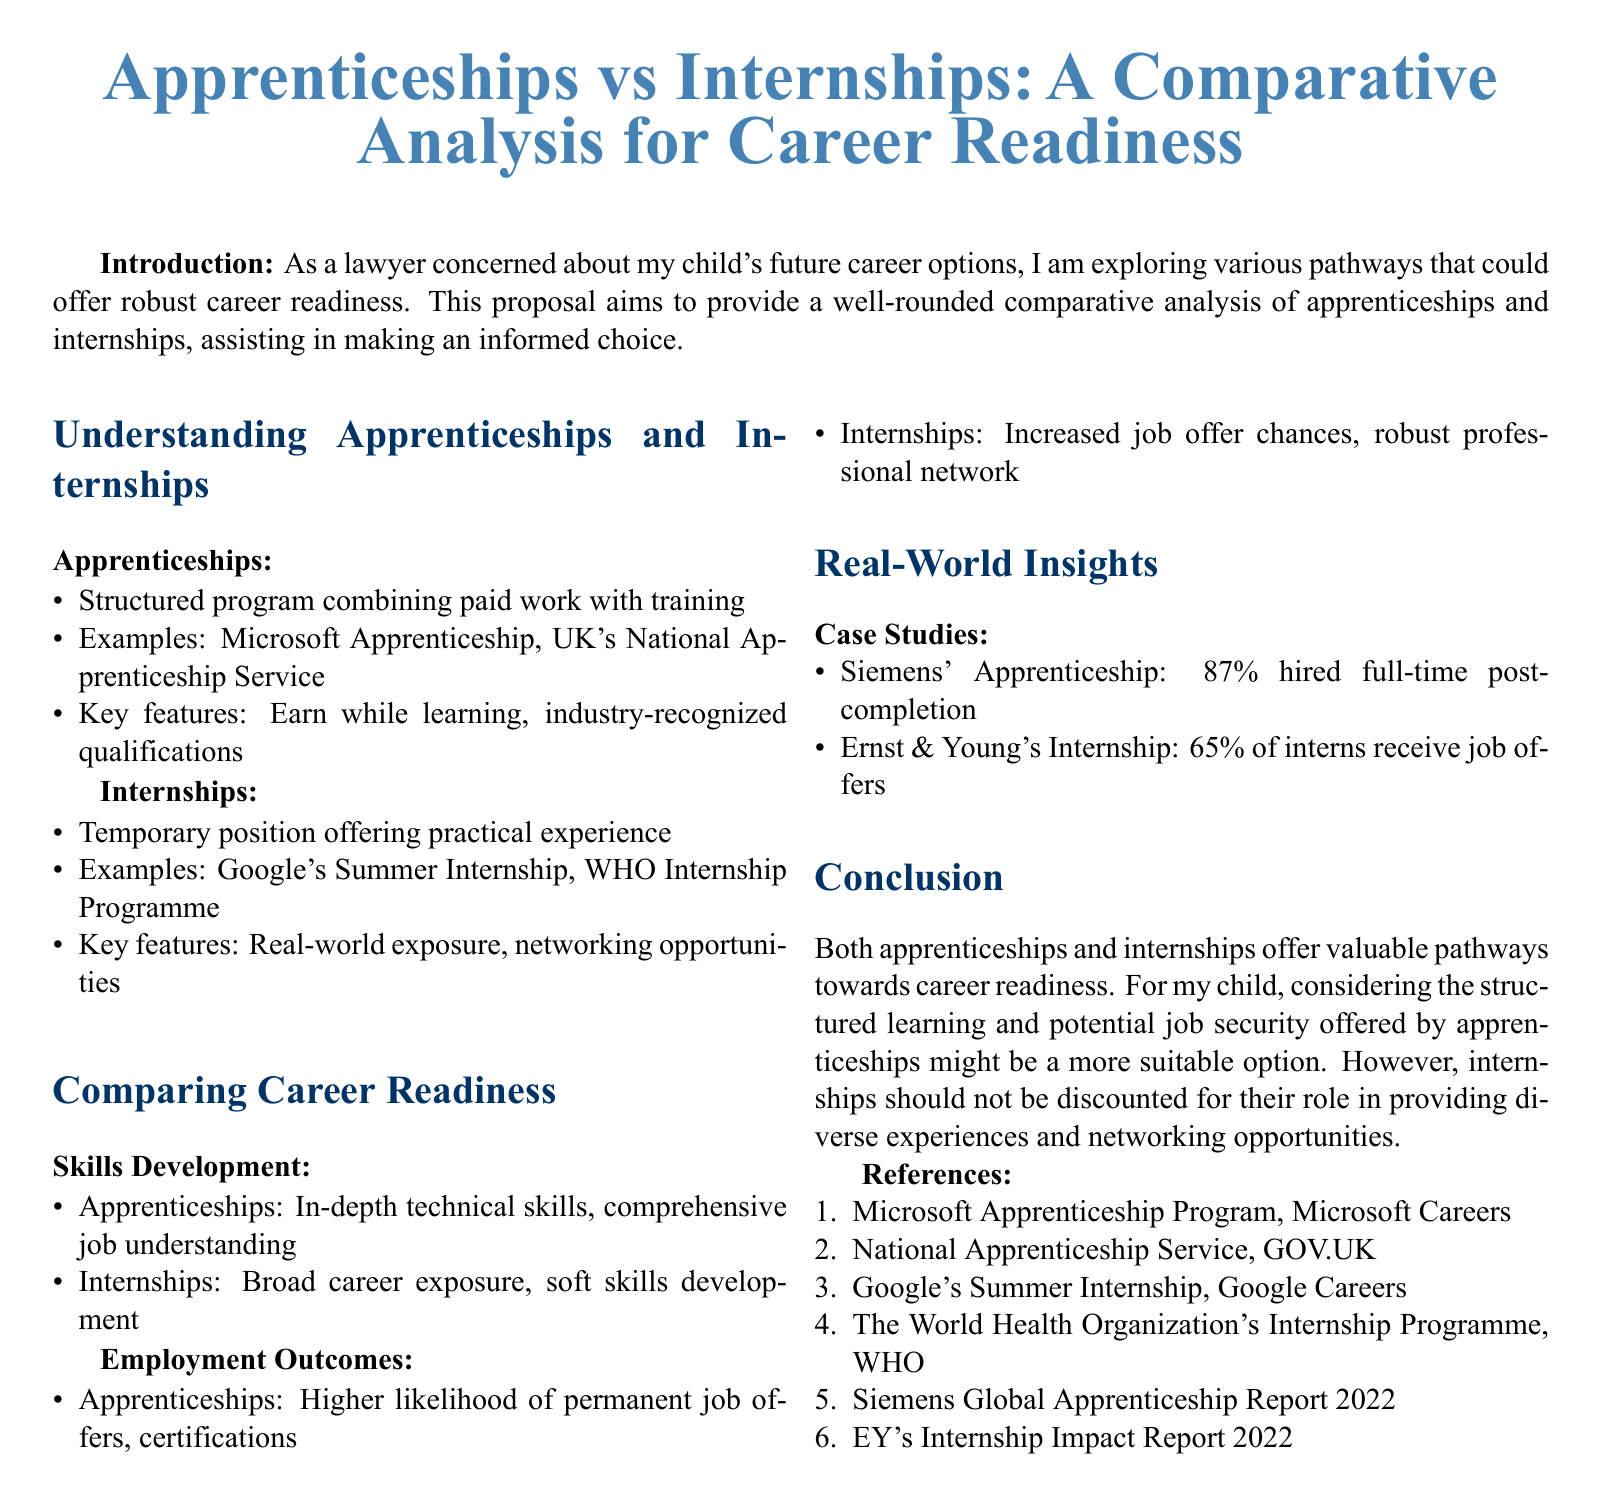What is the main purpose of the proposal? The proposal aims to provide a well-rounded comparative analysis of apprenticeships and internships, assisting in making an informed choice.
Answer: comparative analysis of apprenticeships and internships What percentage of Siemens apprentices were hired full-time post-completion? The document states that 87% of Siemens' apprentices were hired full-time post-completion.
Answer: 87% What is a key feature of apprenticeships? A key feature of apprenticeships is that they offer "Earn while learning, industry-recognized qualifications."
Answer: Earn while learning, industry-recognized qualifications How many internships from Ernst & Young result in job offers? According to the document, 65% of interns at Ernst & Young receive job offers.
Answer: 65% Which program is an example of an internship? The document lists "Google's Summer Internship" as an example of an internship.
Answer: Google's Summer Internship What type of skills do apprenticeships primarily develop? Apprenticeships primarily develop in-depth technical skills and comprehensive job understanding.
Answer: in-depth technical skills What outcome is associated with internships? Internships are associated with increased job offer chances and robust professional networking.
Answer: increased job offer chances What does the conclusion suggest about apprenticeships compared to internships? The conclusion suggests that considering the structured learning and potential job security offered by apprenticeships might be more suitable.
Answer: structured learning and potential job security offered by apprenticeships 